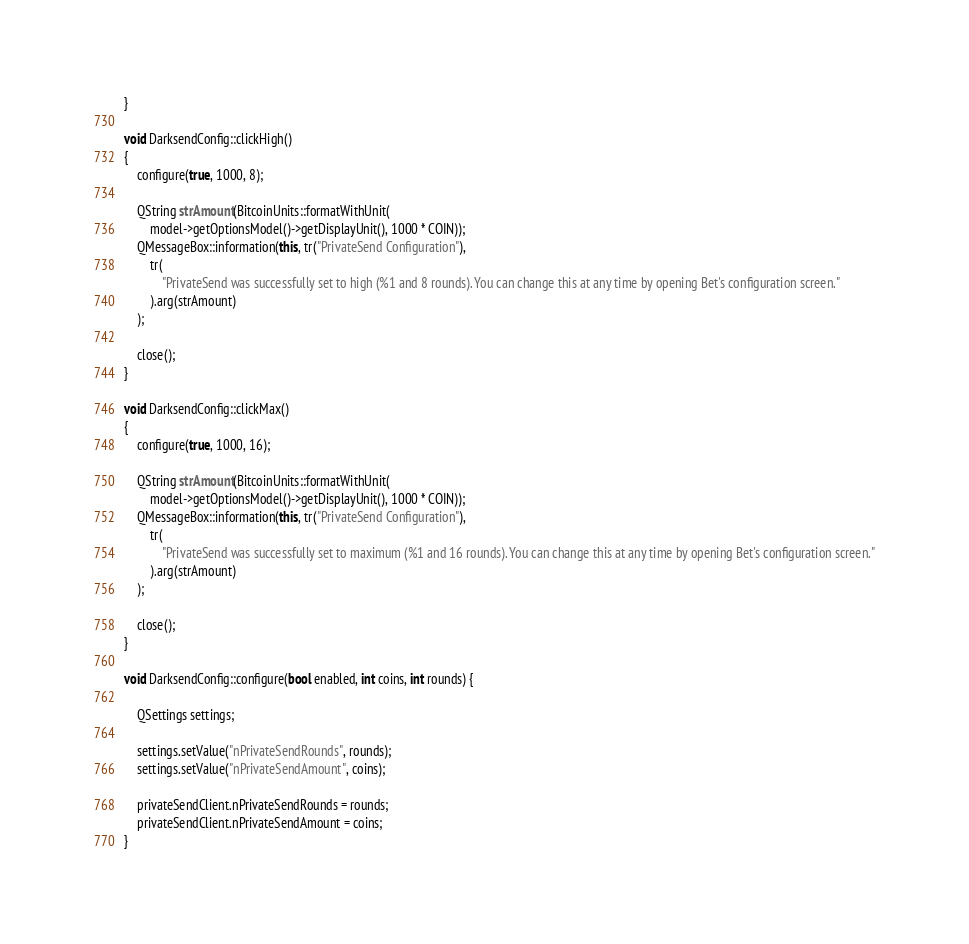Convert code to text. <code><loc_0><loc_0><loc_500><loc_500><_C++_>}

void DarksendConfig::clickHigh()
{
    configure(true, 1000, 8);

    QString strAmount(BitcoinUnits::formatWithUnit(
        model->getOptionsModel()->getDisplayUnit(), 1000 * COIN));
    QMessageBox::information(this, tr("PrivateSend Configuration"),
        tr(
            "PrivateSend was successfully set to high (%1 and 8 rounds). You can change this at any time by opening Bet's configuration screen."
        ).arg(strAmount)
    );

    close();
}

void DarksendConfig::clickMax()
{
    configure(true, 1000, 16);

    QString strAmount(BitcoinUnits::formatWithUnit(
        model->getOptionsModel()->getDisplayUnit(), 1000 * COIN));
    QMessageBox::information(this, tr("PrivateSend Configuration"),
        tr(
            "PrivateSend was successfully set to maximum (%1 and 16 rounds). You can change this at any time by opening Bet's configuration screen."
        ).arg(strAmount)
    );

    close();
}

void DarksendConfig::configure(bool enabled, int coins, int rounds) {

    QSettings settings;

    settings.setValue("nPrivateSendRounds", rounds);
    settings.setValue("nPrivateSendAmount", coins);

    privateSendClient.nPrivateSendRounds = rounds;
    privateSendClient.nPrivateSendAmount = coins;
}
</code> 